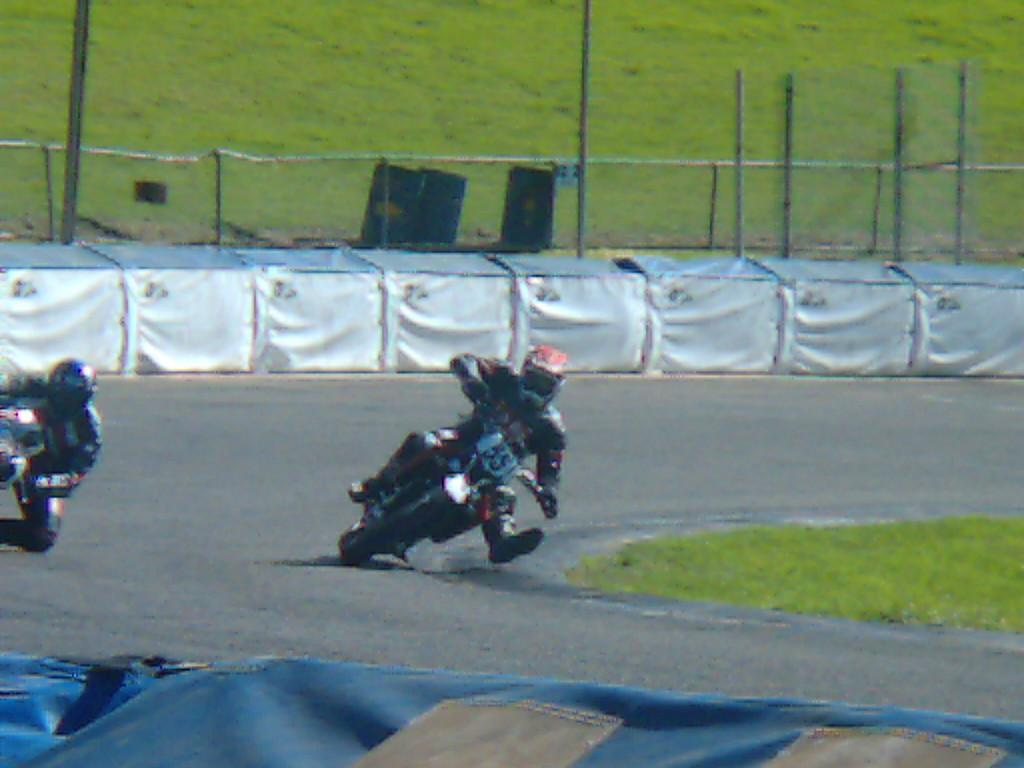What are the two persons in the image doing? The two persons in the image are riding bikes on the road. What is located at the bottom of the image? There is an object at the bottom of the image, but its description is not provided in the facts. What type of vegetation can be seen in the background of the image? There is grass in the background of the image. What structures are visible in the background of the image? There are poles and a fence in the background of the image. What musical instruments can be seen in the background of the image? There are three drums in the background of the image. What other objects can be seen in the background of the image? There are other objects visible in the background of the image, but their specific details are not provided in the facts. What type of wood is being used to build the army barracks in the image? There is no mention of an army or barracks in the image, so it is not possible to determine the type of wood being used. 